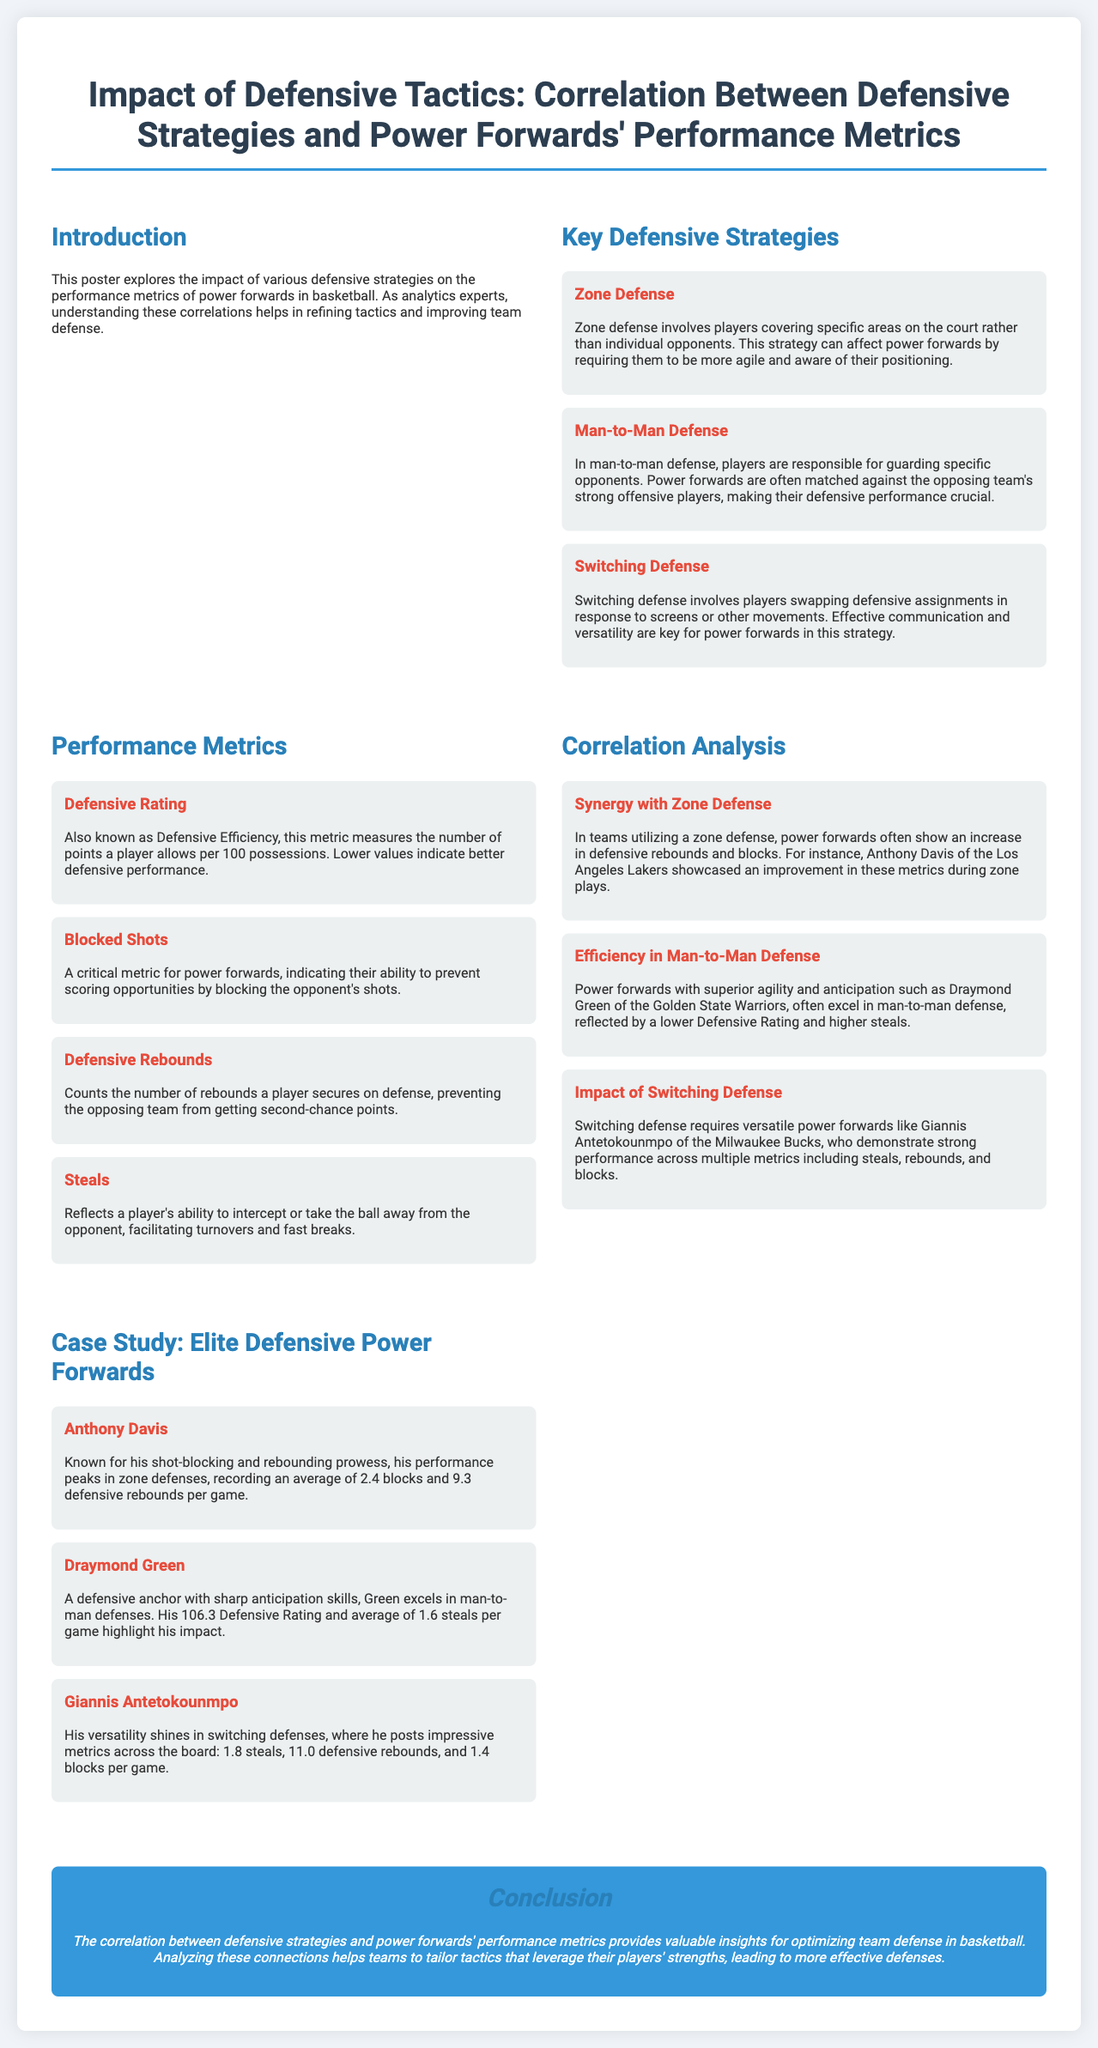What is the title of the poster? The title of the poster can be found at the top, summarizing the main topic of the research.
Answer: Impact of Defensive Tactics: Correlation Between Defensive Strategies and Power Forwards' Performance Metrics What defensive strategy is associated with Anthony Davis? The document explicitly mentions Anthony Davis's performance peaks in zone defenses.
Answer: Zone Defense What is the average number of defensive rebounds posted by Giannis Antetokounmpo? The average defensive rebounds for Giannis Antetokounmpo is provided in the case study section.
Answer: 11.0 Which metric does Draymond Green excel in according to the poster? The poster states that Draymond Green excels particularly in man-to-man defenses, revealing his strong skills in interceptions.
Answer: Steals What is the Defensive Rating of Draymond Green? The document provides his Defensive Rating specifically in the case study section.
Answer: 106.3 How many blocks does Anthony Davis average per game? The performance of Anthony Davis in terms of blocks is highlighted in the case study section.
Answer: 2.4 What key skill is required for switching defense? The document emphasizes effective communication and versatility as essential skills for switching defense.
Answer: Communication What is the main conclusion of the poster? The conclusion summarizes the insights that are drawn from the correlation findings presented in the poster.
Answer: Valuable insights for optimizing team defense in basketball 